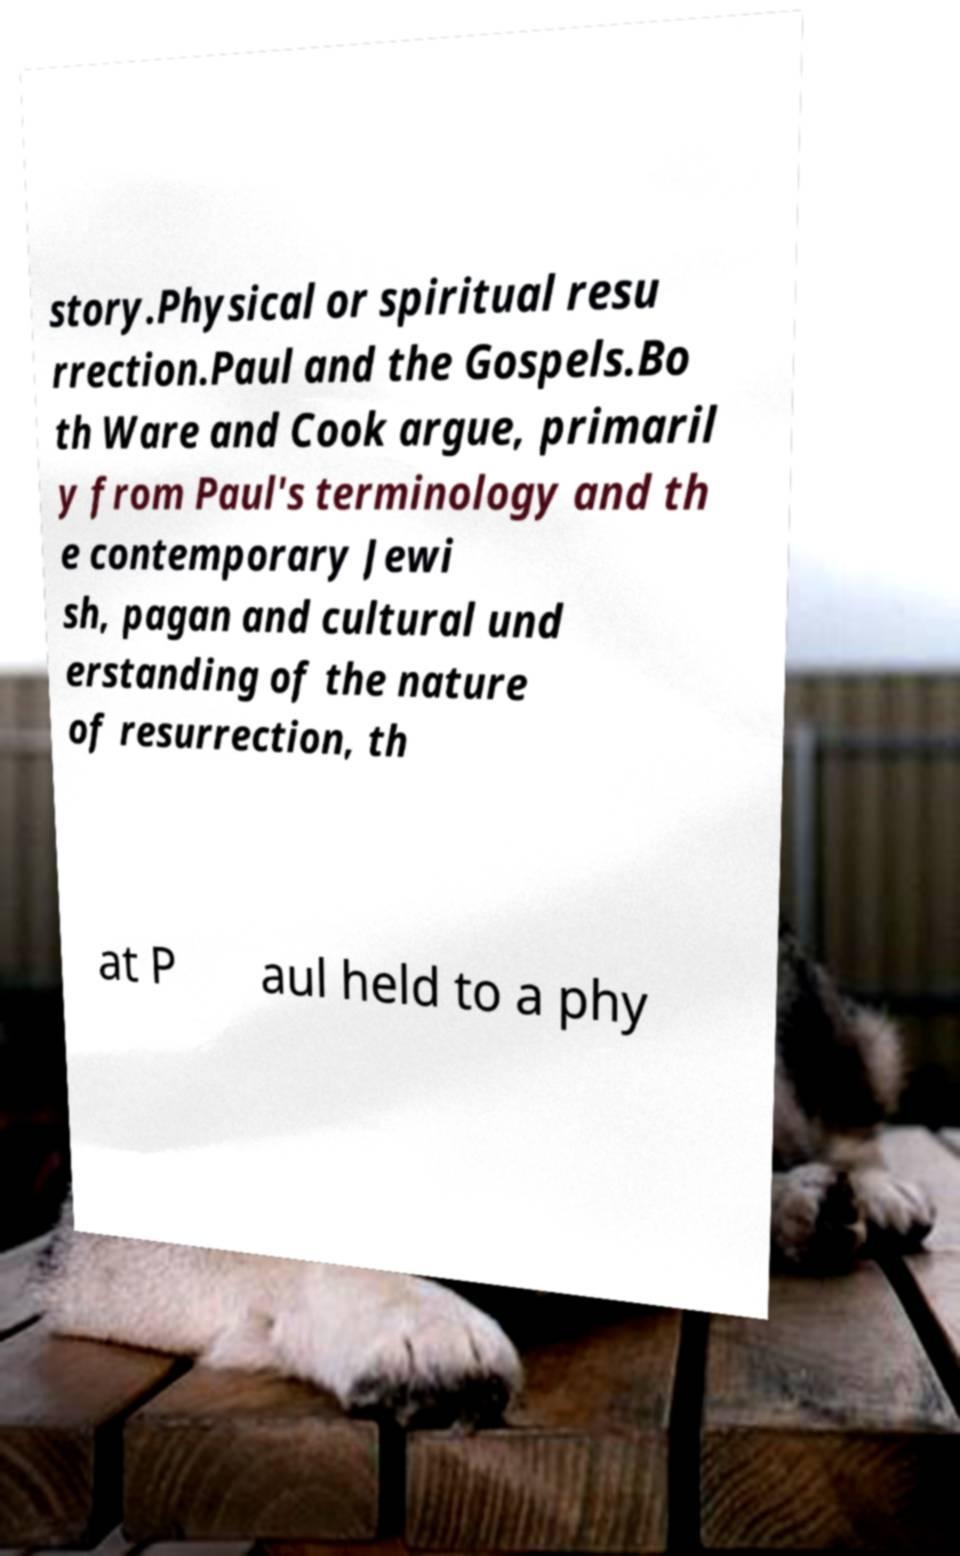Please identify and transcribe the text found in this image. story.Physical or spiritual resu rrection.Paul and the Gospels.Bo th Ware and Cook argue, primaril y from Paul's terminology and th e contemporary Jewi sh, pagan and cultural und erstanding of the nature of resurrection, th at P aul held to a phy 